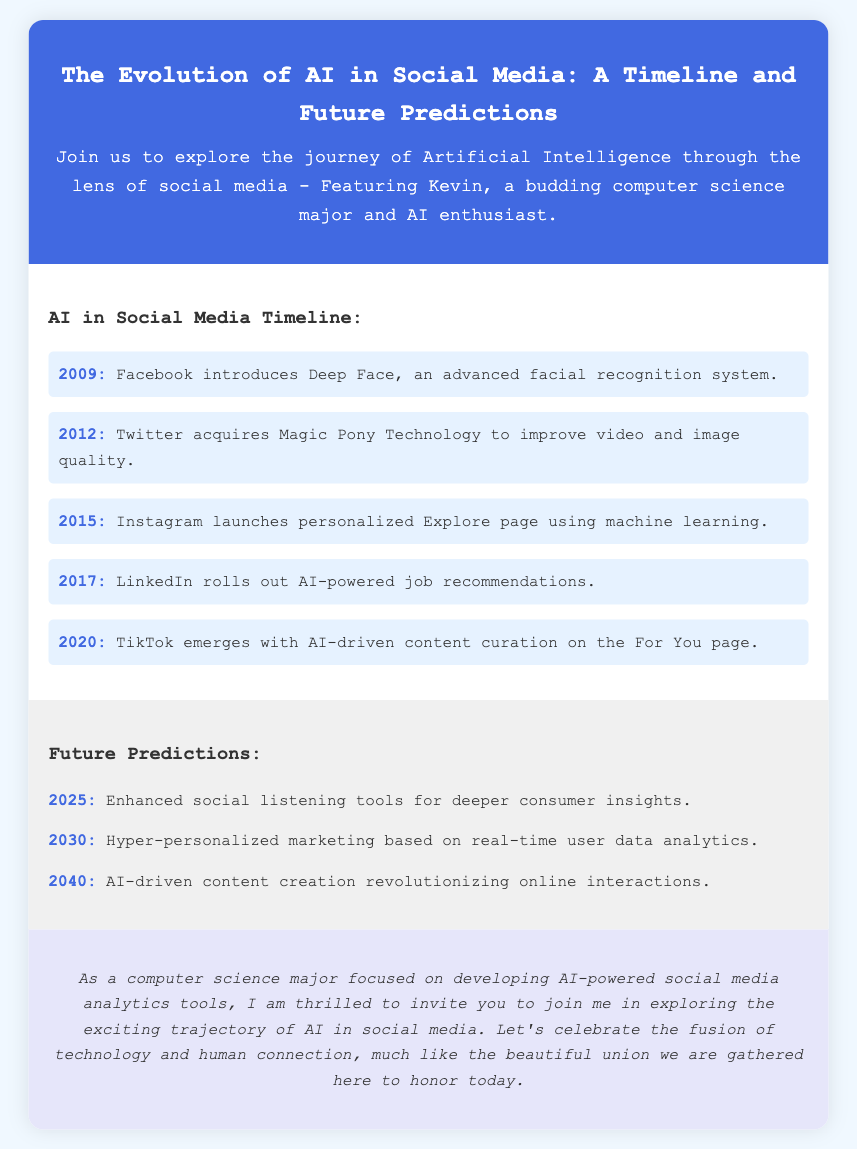What year did Facebook introduce Deep Face? The document states that Facebook introduced Deep Face in the year 2009.
Answer: 2009 Which company acquired Magic Pony Technology? According to the timeline, Twitter is the company that acquired Magic Pony Technology in 2012.
Answer: Twitter What year did TikTok emerge? The document mentions that TikTok emerged in the year 2020 with AI-driven content curation.
Answer: 2020 What is predicted for 2030? The document states that hyper-personalized marketing based on real-time user data analytics is predicted for the year 2030.
Answer: Hyper-personalized marketing Who is the AI enthusiast mentioned in the invitation? The document introduces Kevin as the budding computer science major and AI enthusiast.
Answer: Kevin What is the main theme of the wedding invitation? The theme of the wedding invitation revolves around the exploration of AI in social media, as highlighted in the title and description.
Answer: AI in social media What is a prediction for 2040? The document predicts that AI-driven content creation will revolutionize online interactions in 2040.
Answer: AI-driven content creation In which section is the timeline located? The section containing the timeline is titled "AI in Social Media Timeline."
Answer: AI in Social Media Timeline What is the background color of the document? The background color of the document is specified as #f0f8ff in the styling section.
Answer: #f0f8ff 